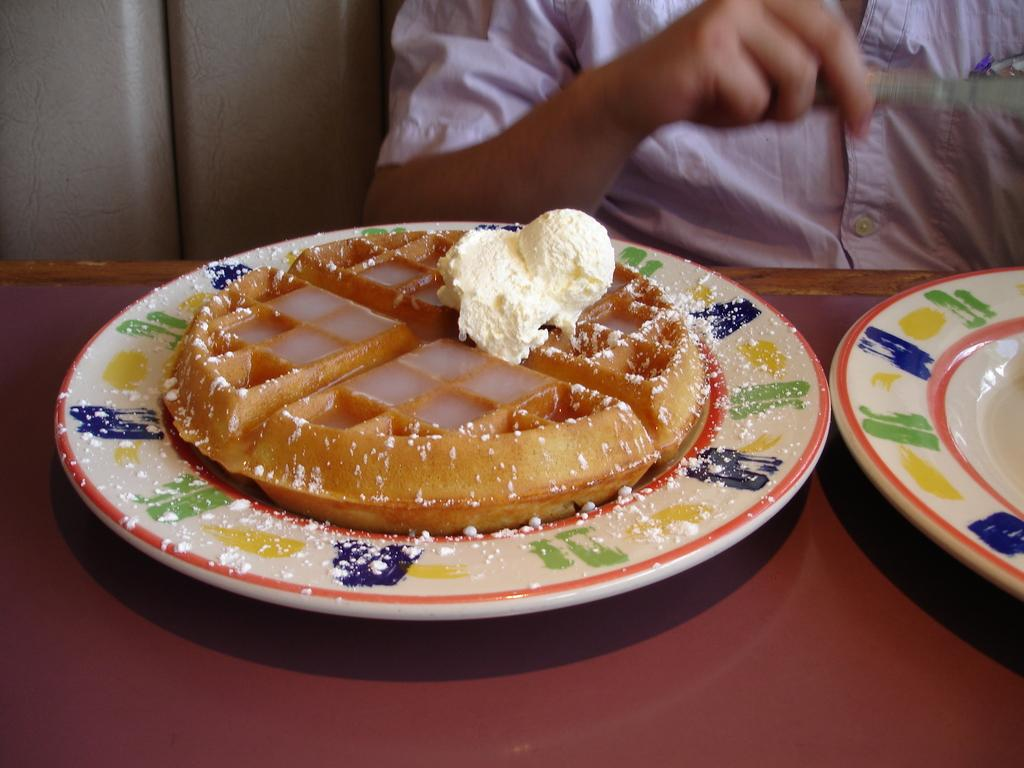How many plates are visible on the platform in the image? There are two plates on the platform in the image. What is on one of the plates? There are food items on one of the plates. Can you describe the person in the image? There is a person in the image, but their specific appearance or actions are not mentioned in the provided facts. What other objects are present in the image besides the plates and food items? There are additional objects present in the image, but their specific nature is not mentioned in the provided facts. Can you tell me how many times the person in the image jumps in the air? There is no information about the person jumping in the image, as the provided facts do not mention any such action. What direction does the station face in the image? There is no mention of a station in the image, so it is impossible to determine its direction. 